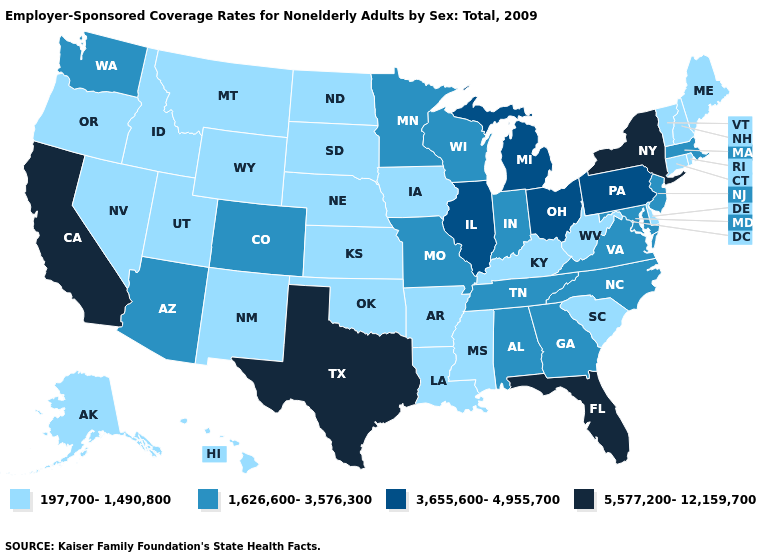Which states hav the highest value in the West?
Short answer required. California. Among the states that border Virginia , does Kentucky have the highest value?
Be succinct. No. Among the states that border Vermont , which have the highest value?
Keep it brief. New York. What is the value of Pennsylvania?
Quick response, please. 3,655,600-4,955,700. What is the lowest value in the USA?
Keep it brief. 197,700-1,490,800. Which states have the highest value in the USA?
Answer briefly. California, Florida, New York, Texas. What is the value of Wisconsin?
Give a very brief answer. 1,626,600-3,576,300. Name the states that have a value in the range 197,700-1,490,800?
Keep it brief. Alaska, Arkansas, Connecticut, Delaware, Hawaii, Idaho, Iowa, Kansas, Kentucky, Louisiana, Maine, Mississippi, Montana, Nebraska, Nevada, New Hampshire, New Mexico, North Dakota, Oklahoma, Oregon, Rhode Island, South Carolina, South Dakota, Utah, Vermont, West Virginia, Wyoming. Among the states that border North Carolina , does South Carolina have the highest value?
Answer briefly. No. Name the states that have a value in the range 5,577,200-12,159,700?
Short answer required. California, Florida, New York, Texas. Does Rhode Island have the highest value in the Northeast?
Quick response, please. No. Does Iowa have a lower value than Tennessee?
Write a very short answer. Yes. Does Arizona have the same value as New Jersey?
Quick response, please. Yes. Among the states that border North Dakota , does South Dakota have the lowest value?
Be succinct. Yes. What is the value of South Dakota?
Give a very brief answer. 197,700-1,490,800. 